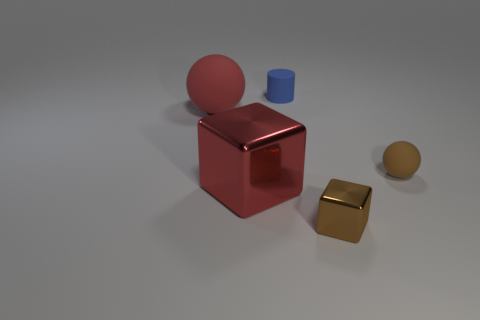What mood or atmosphere do the objects and their arrangement convey? The objects are arranged in a simple yet methodical way, with a sense of balance and minimalism. The muted color palette and soft lighting contribute to a calm and serene atmosphere. 